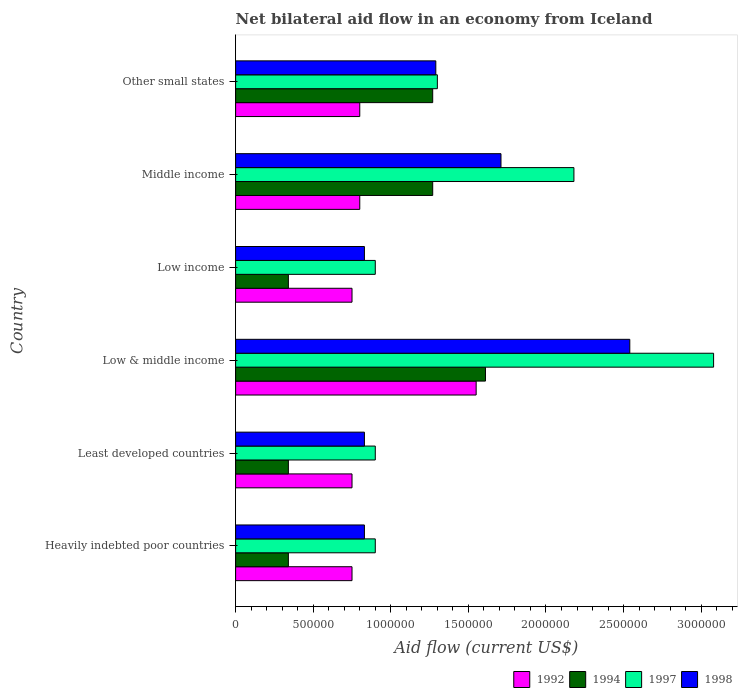How many different coloured bars are there?
Offer a terse response. 4. Are the number of bars on each tick of the Y-axis equal?
Give a very brief answer. Yes. How many bars are there on the 2nd tick from the top?
Give a very brief answer. 4. How many bars are there on the 2nd tick from the bottom?
Your answer should be very brief. 4. What is the label of the 2nd group of bars from the top?
Provide a short and direct response. Middle income. In how many cases, is the number of bars for a given country not equal to the number of legend labels?
Your answer should be very brief. 0. What is the net bilateral aid flow in 1998 in Middle income?
Ensure brevity in your answer.  1.71e+06. Across all countries, what is the maximum net bilateral aid flow in 1998?
Provide a short and direct response. 2.54e+06. Across all countries, what is the minimum net bilateral aid flow in 1998?
Provide a short and direct response. 8.30e+05. In which country was the net bilateral aid flow in 1994 maximum?
Make the answer very short. Low & middle income. In which country was the net bilateral aid flow in 1994 minimum?
Give a very brief answer. Heavily indebted poor countries. What is the total net bilateral aid flow in 1998 in the graph?
Your response must be concise. 8.03e+06. What is the difference between the net bilateral aid flow in 1992 in Low & middle income and that in Middle income?
Your answer should be compact. 7.50e+05. What is the difference between the net bilateral aid flow in 1997 in Other small states and the net bilateral aid flow in 1998 in Low income?
Give a very brief answer. 4.70e+05. What is the average net bilateral aid flow in 1992 per country?
Your response must be concise. 9.00e+05. What is the difference between the net bilateral aid flow in 1997 and net bilateral aid flow in 1994 in Low & middle income?
Give a very brief answer. 1.47e+06. In how many countries, is the net bilateral aid flow in 1998 greater than 2000000 US$?
Give a very brief answer. 1. What is the ratio of the net bilateral aid flow in 1997 in Heavily indebted poor countries to that in Low & middle income?
Keep it short and to the point. 0.29. Is the net bilateral aid flow in 1998 in Heavily indebted poor countries less than that in Low & middle income?
Your answer should be compact. Yes. Is the difference between the net bilateral aid flow in 1997 in Low income and Middle income greater than the difference between the net bilateral aid flow in 1994 in Low income and Middle income?
Your response must be concise. No. What is the difference between the highest and the second highest net bilateral aid flow in 1998?
Ensure brevity in your answer.  8.30e+05. In how many countries, is the net bilateral aid flow in 1994 greater than the average net bilateral aid flow in 1994 taken over all countries?
Provide a short and direct response. 3. Is it the case that in every country, the sum of the net bilateral aid flow in 1992 and net bilateral aid flow in 1998 is greater than the net bilateral aid flow in 1997?
Offer a very short reply. Yes. Are all the bars in the graph horizontal?
Give a very brief answer. Yes. How many countries are there in the graph?
Ensure brevity in your answer.  6. What is the difference between two consecutive major ticks on the X-axis?
Your answer should be very brief. 5.00e+05. Does the graph contain any zero values?
Give a very brief answer. No. Where does the legend appear in the graph?
Keep it short and to the point. Bottom right. How many legend labels are there?
Provide a short and direct response. 4. How are the legend labels stacked?
Your answer should be very brief. Horizontal. What is the title of the graph?
Make the answer very short. Net bilateral aid flow in an economy from Iceland. Does "1966" appear as one of the legend labels in the graph?
Provide a short and direct response. No. What is the label or title of the Y-axis?
Provide a short and direct response. Country. What is the Aid flow (current US$) in 1992 in Heavily indebted poor countries?
Your response must be concise. 7.50e+05. What is the Aid flow (current US$) of 1997 in Heavily indebted poor countries?
Give a very brief answer. 9.00e+05. What is the Aid flow (current US$) in 1998 in Heavily indebted poor countries?
Make the answer very short. 8.30e+05. What is the Aid flow (current US$) of 1992 in Least developed countries?
Keep it short and to the point. 7.50e+05. What is the Aid flow (current US$) in 1994 in Least developed countries?
Your response must be concise. 3.40e+05. What is the Aid flow (current US$) in 1998 in Least developed countries?
Give a very brief answer. 8.30e+05. What is the Aid flow (current US$) of 1992 in Low & middle income?
Offer a terse response. 1.55e+06. What is the Aid flow (current US$) of 1994 in Low & middle income?
Your response must be concise. 1.61e+06. What is the Aid flow (current US$) in 1997 in Low & middle income?
Ensure brevity in your answer.  3.08e+06. What is the Aid flow (current US$) in 1998 in Low & middle income?
Give a very brief answer. 2.54e+06. What is the Aid flow (current US$) of 1992 in Low income?
Provide a short and direct response. 7.50e+05. What is the Aid flow (current US$) in 1997 in Low income?
Keep it short and to the point. 9.00e+05. What is the Aid flow (current US$) in 1998 in Low income?
Ensure brevity in your answer.  8.30e+05. What is the Aid flow (current US$) in 1994 in Middle income?
Keep it short and to the point. 1.27e+06. What is the Aid flow (current US$) in 1997 in Middle income?
Offer a very short reply. 2.18e+06. What is the Aid flow (current US$) in 1998 in Middle income?
Your response must be concise. 1.71e+06. What is the Aid flow (current US$) of 1992 in Other small states?
Provide a succinct answer. 8.00e+05. What is the Aid flow (current US$) of 1994 in Other small states?
Your answer should be compact. 1.27e+06. What is the Aid flow (current US$) in 1997 in Other small states?
Your answer should be very brief. 1.30e+06. What is the Aid flow (current US$) of 1998 in Other small states?
Make the answer very short. 1.29e+06. Across all countries, what is the maximum Aid flow (current US$) in 1992?
Provide a short and direct response. 1.55e+06. Across all countries, what is the maximum Aid flow (current US$) of 1994?
Your response must be concise. 1.61e+06. Across all countries, what is the maximum Aid flow (current US$) of 1997?
Provide a succinct answer. 3.08e+06. Across all countries, what is the maximum Aid flow (current US$) of 1998?
Provide a short and direct response. 2.54e+06. Across all countries, what is the minimum Aid flow (current US$) in 1992?
Your response must be concise. 7.50e+05. Across all countries, what is the minimum Aid flow (current US$) of 1998?
Offer a terse response. 8.30e+05. What is the total Aid flow (current US$) in 1992 in the graph?
Offer a very short reply. 5.40e+06. What is the total Aid flow (current US$) in 1994 in the graph?
Offer a very short reply. 5.17e+06. What is the total Aid flow (current US$) of 1997 in the graph?
Keep it short and to the point. 9.26e+06. What is the total Aid flow (current US$) in 1998 in the graph?
Give a very brief answer. 8.03e+06. What is the difference between the Aid flow (current US$) in 1992 in Heavily indebted poor countries and that in Least developed countries?
Provide a succinct answer. 0. What is the difference between the Aid flow (current US$) in 1998 in Heavily indebted poor countries and that in Least developed countries?
Make the answer very short. 0. What is the difference between the Aid flow (current US$) of 1992 in Heavily indebted poor countries and that in Low & middle income?
Give a very brief answer. -8.00e+05. What is the difference between the Aid flow (current US$) in 1994 in Heavily indebted poor countries and that in Low & middle income?
Ensure brevity in your answer.  -1.27e+06. What is the difference between the Aid flow (current US$) of 1997 in Heavily indebted poor countries and that in Low & middle income?
Your response must be concise. -2.18e+06. What is the difference between the Aid flow (current US$) in 1998 in Heavily indebted poor countries and that in Low & middle income?
Provide a short and direct response. -1.71e+06. What is the difference between the Aid flow (current US$) of 1992 in Heavily indebted poor countries and that in Low income?
Provide a short and direct response. 0. What is the difference between the Aid flow (current US$) of 1994 in Heavily indebted poor countries and that in Low income?
Keep it short and to the point. 0. What is the difference between the Aid flow (current US$) of 1997 in Heavily indebted poor countries and that in Low income?
Ensure brevity in your answer.  0. What is the difference between the Aid flow (current US$) of 1998 in Heavily indebted poor countries and that in Low income?
Your answer should be compact. 0. What is the difference between the Aid flow (current US$) of 1994 in Heavily indebted poor countries and that in Middle income?
Ensure brevity in your answer.  -9.30e+05. What is the difference between the Aid flow (current US$) of 1997 in Heavily indebted poor countries and that in Middle income?
Make the answer very short. -1.28e+06. What is the difference between the Aid flow (current US$) of 1998 in Heavily indebted poor countries and that in Middle income?
Provide a succinct answer. -8.80e+05. What is the difference between the Aid flow (current US$) of 1992 in Heavily indebted poor countries and that in Other small states?
Give a very brief answer. -5.00e+04. What is the difference between the Aid flow (current US$) in 1994 in Heavily indebted poor countries and that in Other small states?
Your response must be concise. -9.30e+05. What is the difference between the Aid flow (current US$) of 1997 in Heavily indebted poor countries and that in Other small states?
Make the answer very short. -4.00e+05. What is the difference between the Aid flow (current US$) in 1998 in Heavily indebted poor countries and that in Other small states?
Offer a very short reply. -4.60e+05. What is the difference between the Aid flow (current US$) of 1992 in Least developed countries and that in Low & middle income?
Ensure brevity in your answer.  -8.00e+05. What is the difference between the Aid flow (current US$) of 1994 in Least developed countries and that in Low & middle income?
Your answer should be compact. -1.27e+06. What is the difference between the Aid flow (current US$) in 1997 in Least developed countries and that in Low & middle income?
Offer a very short reply. -2.18e+06. What is the difference between the Aid flow (current US$) in 1998 in Least developed countries and that in Low & middle income?
Provide a succinct answer. -1.71e+06. What is the difference between the Aid flow (current US$) of 1992 in Least developed countries and that in Low income?
Keep it short and to the point. 0. What is the difference between the Aid flow (current US$) in 1994 in Least developed countries and that in Middle income?
Provide a short and direct response. -9.30e+05. What is the difference between the Aid flow (current US$) in 1997 in Least developed countries and that in Middle income?
Your answer should be very brief. -1.28e+06. What is the difference between the Aid flow (current US$) in 1998 in Least developed countries and that in Middle income?
Provide a short and direct response. -8.80e+05. What is the difference between the Aid flow (current US$) of 1992 in Least developed countries and that in Other small states?
Keep it short and to the point. -5.00e+04. What is the difference between the Aid flow (current US$) in 1994 in Least developed countries and that in Other small states?
Ensure brevity in your answer.  -9.30e+05. What is the difference between the Aid flow (current US$) of 1997 in Least developed countries and that in Other small states?
Your response must be concise. -4.00e+05. What is the difference between the Aid flow (current US$) in 1998 in Least developed countries and that in Other small states?
Keep it short and to the point. -4.60e+05. What is the difference between the Aid flow (current US$) of 1994 in Low & middle income and that in Low income?
Provide a short and direct response. 1.27e+06. What is the difference between the Aid flow (current US$) in 1997 in Low & middle income and that in Low income?
Provide a succinct answer. 2.18e+06. What is the difference between the Aid flow (current US$) in 1998 in Low & middle income and that in Low income?
Make the answer very short. 1.71e+06. What is the difference between the Aid flow (current US$) of 1992 in Low & middle income and that in Middle income?
Your answer should be very brief. 7.50e+05. What is the difference between the Aid flow (current US$) in 1994 in Low & middle income and that in Middle income?
Your answer should be very brief. 3.40e+05. What is the difference between the Aid flow (current US$) in 1997 in Low & middle income and that in Middle income?
Offer a terse response. 9.00e+05. What is the difference between the Aid flow (current US$) of 1998 in Low & middle income and that in Middle income?
Give a very brief answer. 8.30e+05. What is the difference between the Aid flow (current US$) of 1992 in Low & middle income and that in Other small states?
Offer a terse response. 7.50e+05. What is the difference between the Aid flow (current US$) in 1997 in Low & middle income and that in Other small states?
Your answer should be compact. 1.78e+06. What is the difference between the Aid flow (current US$) of 1998 in Low & middle income and that in Other small states?
Your response must be concise. 1.25e+06. What is the difference between the Aid flow (current US$) in 1992 in Low income and that in Middle income?
Provide a short and direct response. -5.00e+04. What is the difference between the Aid flow (current US$) in 1994 in Low income and that in Middle income?
Your answer should be compact. -9.30e+05. What is the difference between the Aid flow (current US$) of 1997 in Low income and that in Middle income?
Give a very brief answer. -1.28e+06. What is the difference between the Aid flow (current US$) in 1998 in Low income and that in Middle income?
Give a very brief answer. -8.80e+05. What is the difference between the Aid flow (current US$) in 1994 in Low income and that in Other small states?
Make the answer very short. -9.30e+05. What is the difference between the Aid flow (current US$) in 1997 in Low income and that in Other small states?
Give a very brief answer. -4.00e+05. What is the difference between the Aid flow (current US$) of 1998 in Low income and that in Other small states?
Offer a very short reply. -4.60e+05. What is the difference between the Aid flow (current US$) in 1994 in Middle income and that in Other small states?
Ensure brevity in your answer.  0. What is the difference between the Aid flow (current US$) of 1997 in Middle income and that in Other small states?
Offer a terse response. 8.80e+05. What is the difference between the Aid flow (current US$) of 1992 in Heavily indebted poor countries and the Aid flow (current US$) of 1997 in Least developed countries?
Keep it short and to the point. -1.50e+05. What is the difference between the Aid flow (current US$) in 1992 in Heavily indebted poor countries and the Aid flow (current US$) in 1998 in Least developed countries?
Offer a terse response. -8.00e+04. What is the difference between the Aid flow (current US$) in 1994 in Heavily indebted poor countries and the Aid flow (current US$) in 1997 in Least developed countries?
Provide a succinct answer. -5.60e+05. What is the difference between the Aid flow (current US$) of 1994 in Heavily indebted poor countries and the Aid flow (current US$) of 1998 in Least developed countries?
Your answer should be very brief. -4.90e+05. What is the difference between the Aid flow (current US$) in 1997 in Heavily indebted poor countries and the Aid flow (current US$) in 1998 in Least developed countries?
Give a very brief answer. 7.00e+04. What is the difference between the Aid flow (current US$) of 1992 in Heavily indebted poor countries and the Aid flow (current US$) of 1994 in Low & middle income?
Keep it short and to the point. -8.60e+05. What is the difference between the Aid flow (current US$) of 1992 in Heavily indebted poor countries and the Aid flow (current US$) of 1997 in Low & middle income?
Give a very brief answer. -2.33e+06. What is the difference between the Aid flow (current US$) in 1992 in Heavily indebted poor countries and the Aid flow (current US$) in 1998 in Low & middle income?
Give a very brief answer. -1.79e+06. What is the difference between the Aid flow (current US$) in 1994 in Heavily indebted poor countries and the Aid flow (current US$) in 1997 in Low & middle income?
Provide a short and direct response. -2.74e+06. What is the difference between the Aid flow (current US$) of 1994 in Heavily indebted poor countries and the Aid flow (current US$) of 1998 in Low & middle income?
Give a very brief answer. -2.20e+06. What is the difference between the Aid flow (current US$) in 1997 in Heavily indebted poor countries and the Aid flow (current US$) in 1998 in Low & middle income?
Give a very brief answer. -1.64e+06. What is the difference between the Aid flow (current US$) of 1992 in Heavily indebted poor countries and the Aid flow (current US$) of 1994 in Low income?
Ensure brevity in your answer.  4.10e+05. What is the difference between the Aid flow (current US$) in 1992 in Heavily indebted poor countries and the Aid flow (current US$) in 1998 in Low income?
Provide a short and direct response. -8.00e+04. What is the difference between the Aid flow (current US$) in 1994 in Heavily indebted poor countries and the Aid flow (current US$) in 1997 in Low income?
Ensure brevity in your answer.  -5.60e+05. What is the difference between the Aid flow (current US$) of 1994 in Heavily indebted poor countries and the Aid flow (current US$) of 1998 in Low income?
Keep it short and to the point. -4.90e+05. What is the difference between the Aid flow (current US$) in 1992 in Heavily indebted poor countries and the Aid flow (current US$) in 1994 in Middle income?
Provide a short and direct response. -5.20e+05. What is the difference between the Aid flow (current US$) in 1992 in Heavily indebted poor countries and the Aid flow (current US$) in 1997 in Middle income?
Ensure brevity in your answer.  -1.43e+06. What is the difference between the Aid flow (current US$) in 1992 in Heavily indebted poor countries and the Aid flow (current US$) in 1998 in Middle income?
Your answer should be compact. -9.60e+05. What is the difference between the Aid flow (current US$) in 1994 in Heavily indebted poor countries and the Aid flow (current US$) in 1997 in Middle income?
Your answer should be very brief. -1.84e+06. What is the difference between the Aid flow (current US$) in 1994 in Heavily indebted poor countries and the Aid flow (current US$) in 1998 in Middle income?
Provide a short and direct response. -1.37e+06. What is the difference between the Aid flow (current US$) of 1997 in Heavily indebted poor countries and the Aid flow (current US$) of 1998 in Middle income?
Keep it short and to the point. -8.10e+05. What is the difference between the Aid flow (current US$) in 1992 in Heavily indebted poor countries and the Aid flow (current US$) in 1994 in Other small states?
Keep it short and to the point. -5.20e+05. What is the difference between the Aid flow (current US$) of 1992 in Heavily indebted poor countries and the Aid flow (current US$) of 1997 in Other small states?
Your answer should be very brief. -5.50e+05. What is the difference between the Aid flow (current US$) in 1992 in Heavily indebted poor countries and the Aid flow (current US$) in 1998 in Other small states?
Make the answer very short. -5.40e+05. What is the difference between the Aid flow (current US$) in 1994 in Heavily indebted poor countries and the Aid flow (current US$) in 1997 in Other small states?
Give a very brief answer. -9.60e+05. What is the difference between the Aid flow (current US$) of 1994 in Heavily indebted poor countries and the Aid flow (current US$) of 1998 in Other small states?
Your response must be concise. -9.50e+05. What is the difference between the Aid flow (current US$) in 1997 in Heavily indebted poor countries and the Aid flow (current US$) in 1998 in Other small states?
Keep it short and to the point. -3.90e+05. What is the difference between the Aid flow (current US$) in 1992 in Least developed countries and the Aid flow (current US$) in 1994 in Low & middle income?
Your response must be concise. -8.60e+05. What is the difference between the Aid flow (current US$) of 1992 in Least developed countries and the Aid flow (current US$) of 1997 in Low & middle income?
Your response must be concise. -2.33e+06. What is the difference between the Aid flow (current US$) in 1992 in Least developed countries and the Aid flow (current US$) in 1998 in Low & middle income?
Keep it short and to the point. -1.79e+06. What is the difference between the Aid flow (current US$) in 1994 in Least developed countries and the Aid flow (current US$) in 1997 in Low & middle income?
Provide a succinct answer. -2.74e+06. What is the difference between the Aid flow (current US$) in 1994 in Least developed countries and the Aid flow (current US$) in 1998 in Low & middle income?
Offer a terse response. -2.20e+06. What is the difference between the Aid flow (current US$) in 1997 in Least developed countries and the Aid flow (current US$) in 1998 in Low & middle income?
Keep it short and to the point. -1.64e+06. What is the difference between the Aid flow (current US$) in 1992 in Least developed countries and the Aid flow (current US$) in 1998 in Low income?
Your response must be concise. -8.00e+04. What is the difference between the Aid flow (current US$) of 1994 in Least developed countries and the Aid flow (current US$) of 1997 in Low income?
Offer a very short reply. -5.60e+05. What is the difference between the Aid flow (current US$) in 1994 in Least developed countries and the Aid flow (current US$) in 1998 in Low income?
Make the answer very short. -4.90e+05. What is the difference between the Aid flow (current US$) of 1997 in Least developed countries and the Aid flow (current US$) of 1998 in Low income?
Your response must be concise. 7.00e+04. What is the difference between the Aid flow (current US$) in 1992 in Least developed countries and the Aid flow (current US$) in 1994 in Middle income?
Keep it short and to the point. -5.20e+05. What is the difference between the Aid flow (current US$) in 1992 in Least developed countries and the Aid flow (current US$) in 1997 in Middle income?
Your answer should be compact. -1.43e+06. What is the difference between the Aid flow (current US$) of 1992 in Least developed countries and the Aid flow (current US$) of 1998 in Middle income?
Your response must be concise. -9.60e+05. What is the difference between the Aid flow (current US$) in 1994 in Least developed countries and the Aid flow (current US$) in 1997 in Middle income?
Provide a succinct answer. -1.84e+06. What is the difference between the Aid flow (current US$) in 1994 in Least developed countries and the Aid flow (current US$) in 1998 in Middle income?
Keep it short and to the point. -1.37e+06. What is the difference between the Aid flow (current US$) of 1997 in Least developed countries and the Aid flow (current US$) of 1998 in Middle income?
Your answer should be compact. -8.10e+05. What is the difference between the Aid flow (current US$) in 1992 in Least developed countries and the Aid flow (current US$) in 1994 in Other small states?
Provide a succinct answer. -5.20e+05. What is the difference between the Aid flow (current US$) of 1992 in Least developed countries and the Aid flow (current US$) of 1997 in Other small states?
Ensure brevity in your answer.  -5.50e+05. What is the difference between the Aid flow (current US$) of 1992 in Least developed countries and the Aid flow (current US$) of 1998 in Other small states?
Your response must be concise. -5.40e+05. What is the difference between the Aid flow (current US$) in 1994 in Least developed countries and the Aid flow (current US$) in 1997 in Other small states?
Offer a terse response. -9.60e+05. What is the difference between the Aid flow (current US$) in 1994 in Least developed countries and the Aid flow (current US$) in 1998 in Other small states?
Your response must be concise. -9.50e+05. What is the difference between the Aid flow (current US$) of 1997 in Least developed countries and the Aid flow (current US$) of 1998 in Other small states?
Ensure brevity in your answer.  -3.90e+05. What is the difference between the Aid flow (current US$) in 1992 in Low & middle income and the Aid flow (current US$) in 1994 in Low income?
Your answer should be compact. 1.21e+06. What is the difference between the Aid flow (current US$) of 1992 in Low & middle income and the Aid flow (current US$) of 1997 in Low income?
Ensure brevity in your answer.  6.50e+05. What is the difference between the Aid flow (current US$) in 1992 in Low & middle income and the Aid flow (current US$) in 1998 in Low income?
Provide a short and direct response. 7.20e+05. What is the difference between the Aid flow (current US$) of 1994 in Low & middle income and the Aid flow (current US$) of 1997 in Low income?
Your answer should be very brief. 7.10e+05. What is the difference between the Aid flow (current US$) of 1994 in Low & middle income and the Aid flow (current US$) of 1998 in Low income?
Keep it short and to the point. 7.80e+05. What is the difference between the Aid flow (current US$) in 1997 in Low & middle income and the Aid flow (current US$) in 1998 in Low income?
Give a very brief answer. 2.25e+06. What is the difference between the Aid flow (current US$) in 1992 in Low & middle income and the Aid flow (current US$) in 1997 in Middle income?
Give a very brief answer. -6.30e+05. What is the difference between the Aid flow (current US$) in 1992 in Low & middle income and the Aid flow (current US$) in 1998 in Middle income?
Your response must be concise. -1.60e+05. What is the difference between the Aid flow (current US$) in 1994 in Low & middle income and the Aid flow (current US$) in 1997 in Middle income?
Keep it short and to the point. -5.70e+05. What is the difference between the Aid flow (current US$) of 1994 in Low & middle income and the Aid flow (current US$) of 1998 in Middle income?
Keep it short and to the point. -1.00e+05. What is the difference between the Aid flow (current US$) of 1997 in Low & middle income and the Aid flow (current US$) of 1998 in Middle income?
Your response must be concise. 1.37e+06. What is the difference between the Aid flow (current US$) of 1992 in Low & middle income and the Aid flow (current US$) of 1994 in Other small states?
Give a very brief answer. 2.80e+05. What is the difference between the Aid flow (current US$) in 1992 in Low & middle income and the Aid flow (current US$) in 1997 in Other small states?
Your answer should be very brief. 2.50e+05. What is the difference between the Aid flow (current US$) of 1994 in Low & middle income and the Aid flow (current US$) of 1998 in Other small states?
Provide a short and direct response. 3.20e+05. What is the difference between the Aid flow (current US$) in 1997 in Low & middle income and the Aid flow (current US$) in 1998 in Other small states?
Your response must be concise. 1.79e+06. What is the difference between the Aid flow (current US$) in 1992 in Low income and the Aid flow (current US$) in 1994 in Middle income?
Offer a very short reply. -5.20e+05. What is the difference between the Aid flow (current US$) in 1992 in Low income and the Aid flow (current US$) in 1997 in Middle income?
Offer a very short reply. -1.43e+06. What is the difference between the Aid flow (current US$) of 1992 in Low income and the Aid flow (current US$) of 1998 in Middle income?
Your response must be concise. -9.60e+05. What is the difference between the Aid flow (current US$) in 1994 in Low income and the Aid flow (current US$) in 1997 in Middle income?
Provide a short and direct response. -1.84e+06. What is the difference between the Aid flow (current US$) in 1994 in Low income and the Aid flow (current US$) in 1998 in Middle income?
Ensure brevity in your answer.  -1.37e+06. What is the difference between the Aid flow (current US$) of 1997 in Low income and the Aid flow (current US$) of 1998 in Middle income?
Your answer should be compact. -8.10e+05. What is the difference between the Aid flow (current US$) of 1992 in Low income and the Aid flow (current US$) of 1994 in Other small states?
Provide a short and direct response. -5.20e+05. What is the difference between the Aid flow (current US$) in 1992 in Low income and the Aid flow (current US$) in 1997 in Other small states?
Provide a short and direct response. -5.50e+05. What is the difference between the Aid flow (current US$) of 1992 in Low income and the Aid flow (current US$) of 1998 in Other small states?
Your answer should be compact. -5.40e+05. What is the difference between the Aid flow (current US$) of 1994 in Low income and the Aid flow (current US$) of 1997 in Other small states?
Your answer should be very brief. -9.60e+05. What is the difference between the Aid flow (current US$) in 1994 in Low income and the Aid flow (current US$) in 1998 in Other small states?
Your answer should be very brief. -9.50e+05. What is the difference between the Aid flow (current US$) of 1997 in Low income and the Aid flow (current US$) of 1998 in Other small states?
Provide a succinct answer. -3.90e+05. What is the difference between the Aid flow (current US$) of 1992 in Middle income and the Aid flow (current US$) of 1994 in Other small states?
Give a very brief answer. -4.70e+05. What is the difference between the Aid flow (current US$) in 1992 in Middle income and the Aid flow (current US$) in 1997 in Other small states?
Ensure brevity in your answer.  -5.00e+05. What is the difference between the Aid flow (current US$) of 1992 in Middle income and the Aid flow (current US$) of 1998 in Other small states?
Offer a very short reply. -4.90e+05. What is the difference between the Aid flow (current US$) of 1994 in Middle income and the Aid flow (current US$) of 1997 in Other small states?
Give a very brief answer. -3.00e+04. What is the difference between the Aid flow (current US$) in 1994 in Middle income and the Aid flow (current US$) in 1998 in Other small states?
Give a very brief answer. -2.00e+04. What is the difference between the Aid flow (current US$) in 1997 in Middle income and the Aid flow (current US$) in 1998 in Other small states?
Your response must be concise. 8.90e+05. What is the average Aid flow (current US$) in 1992 per country?
Offer a terse response. 9.00e+05. What is the average Aid flow (current US$) in 1994 per country?
Your response must be concise. 8.62e+05. What is the average Aid flow (current US$) in 1997 per country?
Provide a short and direct response. 1.54e+06. What is the average Aid flow (current US$) of 1998 per country?
Your response must be concise. 1.34e+06. What is the difference between the Aid flow (current US$) of 1992 and Aid flow (current US$) of 1997 in Heavily indebted poor countries?
Provide a succinct answer. -1.50e+05. What is the difference between the Aid flow (current US$) of 1994 and Aid flow (current US$) of 1997 in Heavily indebted poor countries?
Your answer should be very brief. -5.60e+05. What is the difference between the Aid flow (current US$) of 1994 and Aid flow (current US$) of 1998 in Heavily indebted poor countries?
Provide a succinct answer. -4.90e+05. What is the difference between the Aid flow (current US$) in 1997 and Aid flow (current US$) in 1998 in Heavily indebted poor countries?
Your answer should be very brief. 7.00e+04. What is the difference between the Aid flow (current US$) in 1992 and Aid flow (current US$) in 1994 in Least developed countries?
Offer a very short reply. 4.10e+05. What is the difference between the Aid flow (current US$) in 1992 and Aid flow (current US$) in 1997 in Least developed countries?
Ensure brevity in your answer.  -1.50e+05. What is the difference between the Aid flow (current US$) of 1994 and Aid flow (current US$) of 1997 in Least developed countries?
Your response must be concise. -5.60e+05. What is the difference between the Aid flow (current US$) of 1994 and Aid flow (current US$) of 1998 in Least developed countries?
Provide a short and direct response. -4.90e+05. What is the difference between the Aid flow (current US$) of 1992 and Aid flow (current US$) of 1994 in Low & middle income?
Your answer should be very brief. -6.00e+04. What is the difference between the Aid flow (current US$) in 1992 and Aid flow (current US$) in 1997 in Low & middle income?
Ensure brevity in your answer.  -1.53e+06. What is the difference between the Aid flow (current US$) of 1992 and Aid flow (current US$) of 1998 in Low & middle income?
Your response must be concise. -9.90e+05. What is the difference between the Aid flow (current US$) in 1994 and Aid flow (current US$) in 1997 in Low & middle income?
Provide a short and direct response. -1.47e+06. What is the difference between the Aid flow (current US$) of 1994 and Aid flow (current US$) of 1998 in Low & middle income?
Provide a succinct answer. -9.30e+05. What is the difference between the Aid flow (current US$) of 1997 and Aid flow (current US$) of 1998 in Low & middle income?
Ensure brevity in your answer.  5.40e+05. What is the difference between the Aid flow (current US$) of 1992 and Aid flow (current US$) of 1994 in Low income?
Ensure brevity in your answer.  4.10e+05. What is the difference between the Aid flow (current US$) in 1992 and Aid flow (current US$) in 1998 in Low income?
Offer a terse response. -8.00e+04. What is the difference between the Aid flow (current US$) of 1994 and Aid flow (current US$) of 1997 in Low income?
Offer a terse response. -5.60e+05. What is the difference between the Aid flow (current US$) of 1994 and Aid flow (current US$) of 1998 in Low income?
Make the answer very short. -4.90e+05. What is the difference between the Aid flow (current US$) in 1997 and Aid flow (current US$) in 1998 in Low income?
Make the answer very short. 7.00e+04. What is the difference between the Aid flow (current US$) in 1992 and Aid flow (current US$) in 1994 in Middle income?
Offer a terse response. -4.70e+05. What is the difference between the Aid flow (current US$) of 1992 and Aid flow (current US$) of 1997 in Middle income?
Give a very brief answer. -1.38e+06. What is the difference between the Aid flow (current US$) of 1992 and Aid flow (current US$) of 1998 in Middle income?
Your answer should be very brief. -9.10e+05. What is the difference between the Aid flow (current US$) in 1994 and Aid flow (current US$) in 1997 in Middle income?
Your response must be concise. -9.10e+05. What is the difference between the Aid flow (current US$) of 1994 and Aid flow (current US$) of 1998 in Middle income?
Your response must be concise. -4.40e+05. What is the difference between the Aid flow (current US$) of 1997 and Aid flow (current US$) of 1998 in Middle income?
Your answer should be compact. 4.70e+05. What is the difference between the Aid flow (current US$) of 1992 and Aid flow (current US$) of 1994 in Other small states?
Your answer should be very brief. -4.70e+05. What is the difference between the Aid flow (current US$) of 1992 and Aid flow (current US$) of 1997 in Other small states?
Provide a succinct answer. -5.00e+05. What is the difference between the Aid flow (current US$) in 1992 and Aid flow (current US$) in 1998 in Other small states?
Offer a very short reply. -4.90e+05. What is the ratio of the Aid flow (current US$) of 1994 in Heavily indebted poor countries to that in Least developed countries?
Provide a succinct answer. 1. What is the ratio of the Aid flow (current US$) of 1997 in Heavily indebted poor countries to that in Least developed countries?
Keep it short and to the point. 1. What is the ratio of the Aid flow (current US$) of 1992 in Heavily indebted poor countries to that in Low & middle income?
Provide a short and direct response. 0.48. What is the ratio of the Aid flow (current US$) of 1994 in Heavily indebted poor countries to that in Low & middle income?
Your answer should be compact. 0.21. What is the ratio of the Aid flow (current US$) of 1997 in Heavily indebted poor countries to that in Low & middle income?
Offer a very short reply. 0.29. What is the ratio of the Aid flow (current US$) of 1998 in Heavily indebted poor countries to that in Low & middle income?
Provide a short and direct response. 0.33. What is the ratio of the Aid flow (current US$) in 1994 in Heavily indebted poor countries to that in Low income?
Ensure brevity in your answer.  1. What is the ratio of the Aid flow (current US$) of 1992 in Heavily indebted poor countries to that in Middle income?
Your response must be concise. 0.94. What is the ratio of the Aid flow (current US$) of 1994 in Heavily indebted poor countries to that in Middle income?
Keep it short and to the point. 0.27. What is the ratio of the Aid flow (current US$) of 1997 in Heavily indebted poor countries to that in Middle income?
Your answer should be very brief. 0.41. What is the ratio of the Aid flow (current US$) in 1998 in Heavily indebted poor countries to that in Middle income?
Keep it short and to the point. 0.49. What is the ratio of the Aid flow (current US$) in 1992 in Heavily indebted poor countries to that in Other small states?
Provide a succinct answer. 0.94. What is the ratio of the Aid flow (current US$) in 1994 in Heavily indebted poor countries to that in Other small states?
Provide a short and direct response. 0.27. What is the ratio of the Aid flow (current US$) in 1997 in Heavily indebted poor countries to that in Other small states?
Offer a terse response. 0.69. What is the ratio of the Aid flow (current US$) of 1998 in Heavily indebted poor countries to that in Other small states?
Offer a very short reply. 0.64. What is the ratio of the Aid flow (current US$) in 1992 in Least developed countries to that in Low & middle income?
Offer a very short reply. 0.48. What is the ratio of the Aid flow (current US$) of 1994 in Least developed countries to that in Low & middle income?
Your response must be concise. 0.21. What is the ratio of the Aid flow (current US$) of 1997 in Least developed countries to that in Low & middle income?
Give a very brief answer. 0.29. What is the ratio of the Aid flow (current US$) in 1998 in Least developed countries to that in Low & middle income?
Offer a terse response. 0.33. What is the ratio of the Aid flow (current US$) of 1994 in Least developed countries to that in Low income?
Provide a succinct answer. 1. What is the ratio of the Aid flow (current US$) in 1997 in Least developed countries to that in Low income?
Give a very brief answer. 1. What is the ratio of the Aid flow (current US$) in 1994 in Least developed countries to that in Middle income?
Provide a succinct answer. 0.27. What is the ratio of the Aid flow (current US$) in 1997 in Least developed countries to that in Middle income?
Your response must be concise. 0.41. What is the ratio of the Aid flow (current US$) in 1998 in Least developed countries to that in Middle income?
Keep it short and to the point. 0.49. What is the ratio of the Aid flow (current US$) of 1994 in Least developed countries to that in Other small states?
Offer a very short reply. 0.27. What is the ratio of the Aid flow (current US$) in 1997 in Least developed countries to that in Other small states?
Offer a terse response. 0.69. What is the ratio of the Aid flow (current US$) of 1998 in Least developed countries to that in Other small states?
Ensure brevity in your answer.  0.64. What is the ratio of the Aid flow (current US$) of 1992 in Low & middle income to that in Low income?
Give a very brief answer. 2.07. What is the ratio of the Aid flow (current US$) in 1994 in Low & middle income to that in Low income?
Make the answer very short. 4.74. What is the ratio of the Aid flow (current US$) of 1997 in Low & middle income to that in Low income?
Give a very brief answer. 3.42. What is the ratio of the Aid flow (current US$) of 1998 in Low & middle income to that in Low income?
Your answer should be compact. 3.06. What is the ratio of the Aid flow (current US$) of 1992 in Low & middle income to that in Middle income?
Provide a short and direct response. 1.94. What is the ratio of the Aid flow (current US$) in 1994 in Low & middle income to that in Middle income?
Keep it short and to the point. 1.27. What is the ratio of the Aid flow (current US$) of 1997 in Low & middle income to that in Middle income?
Offer a very short reply. 1.41. What is the ratio of the Aid flow (current US$) of 1998 in Low & middle income to that in Middle income?
Offer a terse response. 1.49. What is the ratio of the Aid flow (current US$) in 1992 in Low & middle income to that in Other small states?
Offer a very short reply. 1.94. What is the ratio of the Aid flow (current US$) in 1994 in Low & middle income to that in Other small states?
Provide a short and direct response. 1.27. What is the ratio of the Aid flow (current US$) in 1997 in Low & middle income to that in Other small states?
Give a very brief answer. 2.37. What is the ratio of the Aid flow (current US$) in 1998 in Low & middle income to that in Other small states?
Offer a very short reply. 1.97. What is the ratio of the Aid flow (current US$) in 1994 in Low income to that in Middle income?
Offer a very short reply. 0.27. What is the ratio of the Aid flow (current US$) in 1997 in Low income to that in Middle income?
Your answer should be very brief. 0.41. What is the ratio of the Aid flow (current US$) of 1998 in Low income to that in Middle income?
Offer a very short reply. 0.49. What is the ratio of the Aid flow (current US$) of 1992 in Low income to that in Other small states?
Provide a succinct answer. 0.94. What is the ratio of the Aid flow (current US$) in 1994 in Low income to that in Other small states?
Make the answer very short. 0.27. What is the ratio of the Aid flow (current US$) in 1997 in Low income to that in Other small states?
Give a very brief answer. 0.69. What is the ratio of the Aid flow (current US$) of 1998 in Low income to that in Other small states?
Offer a very short reply. 0.64. What is the ratio of the Aid flow (current US$) of 1992 in Middle income to that in Other small states?
Your response must be concise. 1. What is the ratio of the Aid flow (current US$) in 1997 in Middle income to that in Other small states?
Provide a short and direct response. 1.68. What is the ratio of the Aid flow (current US$) of 1998 in Middle income to that in Other small states?
Provide a succinct answer. 1.33. What is the difference between the highest and the second highest Aid flow (current US$) of 1992?
Keep it short and to the point. 7.50e+05. What is the difference between the highest and the second highest Aid flow (current US$) in 1994?
Make the answer very short. 3.40e+05. What is the difference between the highest and the second highest Aid flow (current US$) of 1998?
Make the answer very short. 8.30e+05. What is the difference between the highest and the lowest Aid flow (current US$) of 1992?
Provide a succinct answer. 8.00e+05. What is the difference between the highest and the lowest Aid flow (current US$) of 1994?
Provide a succinct answer. 1.27e+06. What is the difference between the highest and the lowest Aid flow (current US$) in 1997?
Give a very brief answer. 2.18e+06. What is the difference between the highest and the lowest Aid flow (current US$) of 1998?
Keep it short and to the point. 1.71e+06. 